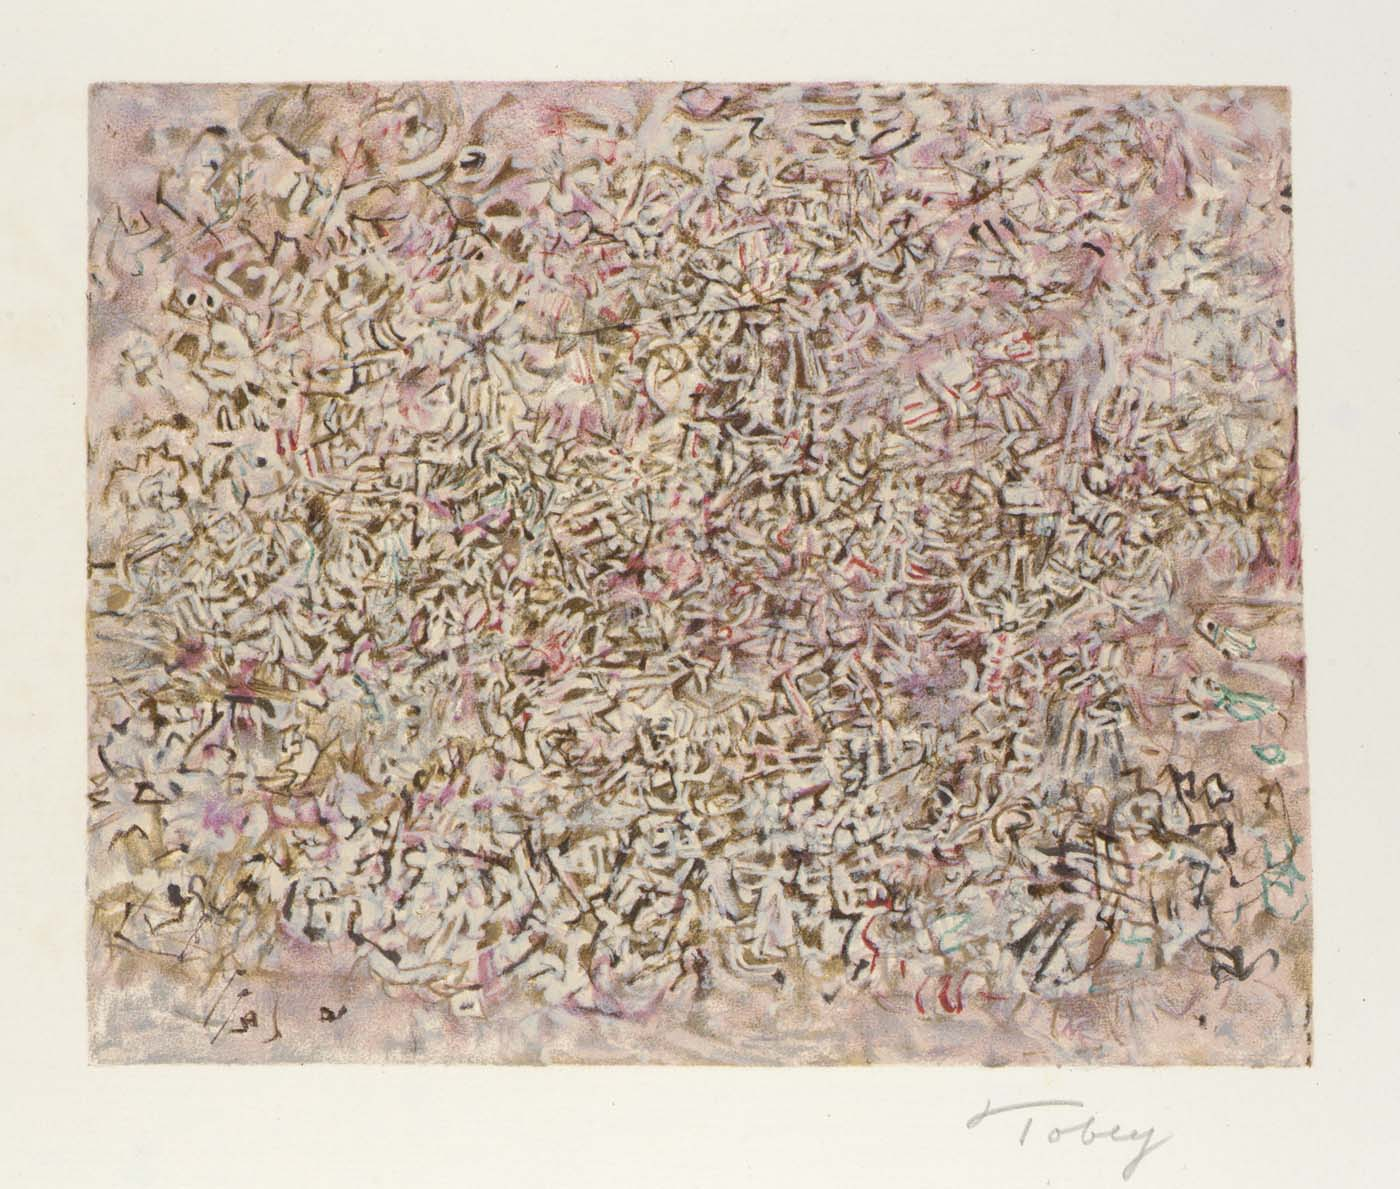Can you explain the significance of the colors used in this painting? The choice of colors in this painting—mainly shades of pink, gray, white, with hints of red and blue—is significant as it sets a somewhat muted yet impactful visual tone. Pink and gray can convey softness and neutrality respectively, providing a subtle background that contrasts with the vibrancy of red and the calmness of blue. These colors might be used to evoke particular moods or emotions, or to highlight certain aspects of the chaotic forms throughout the artwork. The interplay of these colors enhances the overall sense of complexity and depth in the painting. How do these colors influence the viewer's perception of the artwork? The use of these colors can influence the viewer's perception by guiding their emotional response to the artwork. Muted tones like pink and gray may create a soothing backdrop, allowing the bursts of red to stand out, potentially drawing the viewer's focus to specific areas and creating a feeling of energy or intensity. The subtle touches of blue can offer moments of calm within the chaos, giving the viewer's eye a place to rest. Overall, these color choices contribute to an engaging visual experience that may stir introspection and varied interpretations. 